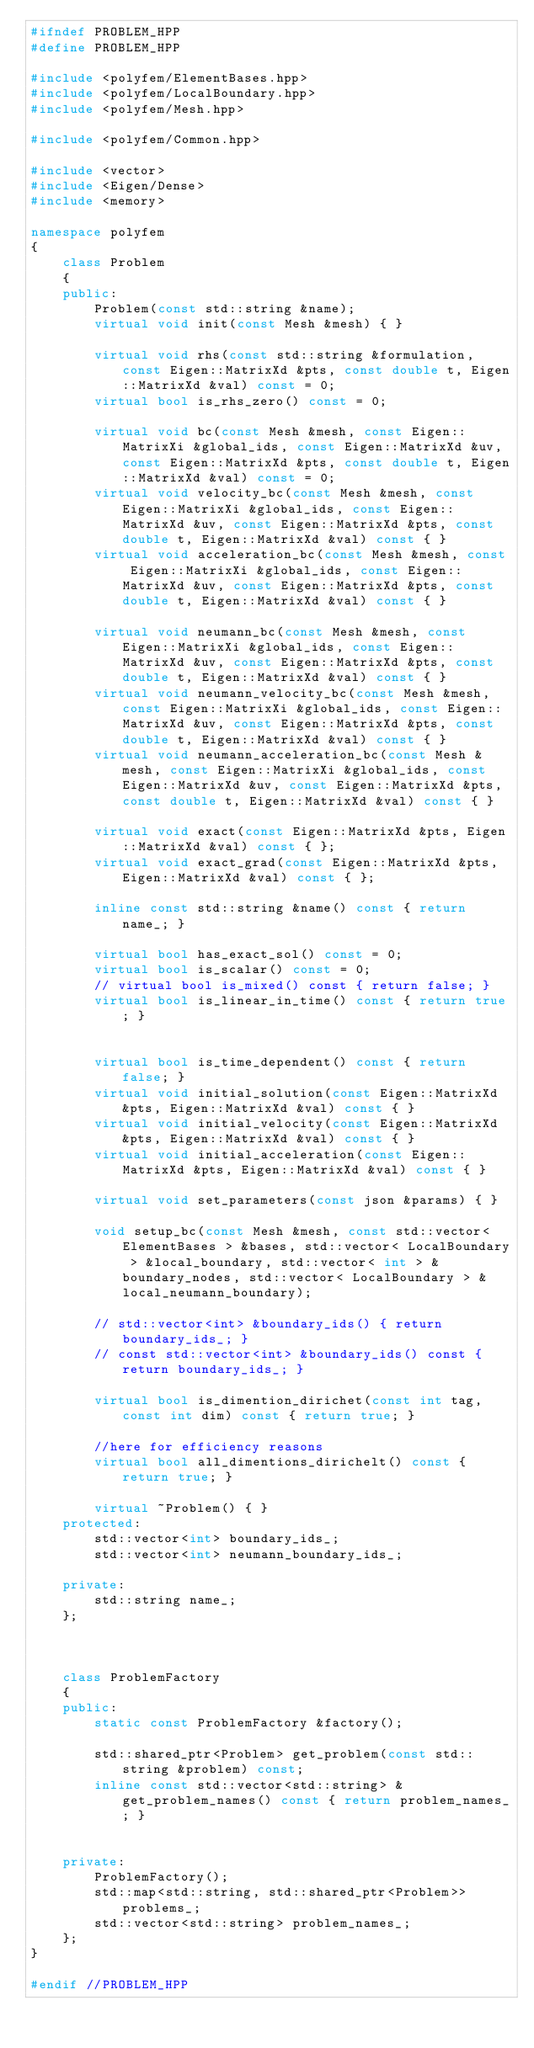Convert code to text. <code><loc_0><loc_0><loc_500><loc_500><_C++_>#ifndef PROBLEM_HPP
#define PROBLEM_HPP

#include <polyfem/ElementBases.hpp>
#include <polyfem/LocalBoundary.hpp>
#include <polyfem/Mesh.hpp>

#include <polyfem/Common.hpp>

#include <vector>
#include <Eigen/Dense>
#include <memory>

namespace polyfem
{
	class Problem
	{
	public:
		Problem(const std::string &name);
		virtual void init(const Mesh &mesh) { }

		virtual void rhs(const std::string &formulation, const Eigen::MatrixXd &pts, const double t, Eigen::MatrixXd &val) const = 0;
		virtual bool is_rhs_zero() const = 0;

		virtual void bc(const Mesh &mesh, const Eigen::MatrixXi &global_ids, const Eigen::MatrixXd &uv, const Eigen::MatrixXd &pts, const double t, Eigen::MatrixXd &val) const = 0;
		virtual void velocity_bc(const Mesh &mesh, const Eigen::MatrixXi &global_ids, const Eigen::MatrixXd &uv, const Eigen::MatrixXd &pts, const double t, Eigen::MatrixXd &val) const { }
		virtual void acceleration_bc(const Mesh &mesh, const Eigen::MatrixXi &global_ids, const Eigen::MatrixXd &uv, const Eigen::MatrixXd &pts, const double t, Eigen::MatrixXd &val) const { }

		virtual void neumann_bc(const Mesh &mesh, const Eigen::MatrixXi &global_ids, const Eigen::MatrixXd &uv, const Eigen::MatrixXd &pts, const double t, Eigen::MatrixXd &val) const { }
		virtual void neumann_velocity_bc(const Mesh &mesh, const Eigen::MatrixXi &global_ids, const Eigen::MatrixXd &uv, const Eigen::MatrixXd &pts, const double t, Eigen::MatrixXd &val) const { }
		virtual void neumann_acceleration_bc(const Mesh &mesh, const Eigen::MatrixXi &global_ids, const Eigen::MatrixXd &uv, const Eigen::MatrixXd &pts, const double t, Eigen::MatrixXd &val) const { }

		virtual void exact(const Eigen::MatrixXd &pts, Eigen::MatrixXd &val) const { };
		virtual void exact_grad(const Eigen::MatrixXd &pts, Eigen::MatrixXd &val) const { };

		inline const std::string &name() const { return name_; }

		virtual bool has_exact_sol() const = 0;
		virtual bool is_scalar() const = 0;
		// virtual bool is_mixed() const { return false; }
		virtual bool is_linear_in_time() const { return true; }


		virtual bool is_time_dependent() const { return false; }
		virtual void initial_solution(const Eigen::MatrixXd &pts, Eigen::MatrixXd &val) const { }
		virtual void initial_velocity(const Eigen::MatrixXd &pts, Eigen::MatrixXd &val) const { }
		virtual void initial_acceleration(const Eigen::MatrixXd &pts, Eigen::MatrixXd &val) const { }

		virtual void set_parameters(const json &params) { }

		void setup_bc(const Mesh &mesh, const std::vector< ElementBases > &bases, std::vector< LocalBoundary > &local_boundary, std::vector< int > &boundary_nodes, std::vector< LocalBoundary > &local_neumann_boundary);

		// std::vector<int> &boundary_ids() { return boundary_ids_; }
		// const std::vector<int> &boundary_ids() const { return boundary_ids_; }

		virtual bool is_dimention_dirichet(const int tag, const int dim) const { return true; }

		//here for efficiency reasons
		virtual bool all_dimentions_dirichelt() const { return true; }

		virtual ~Problem() { }
	protected:
		std::vector<int> boundary_ids_;
		std::vector<int> neumann_boundary_ids_;

	private:
		std::string name_;
	};



	class ProblemFactory
	{
	public:
		static const ProblemFactory &factory();

		std::shared_ptr<Problem> get_problem(const std::string &problem) const;
		inline const std::vector<std::string> &get_problem_names() const { return problem_names_; }


	private:
		ProblemFactory();
		std::map<std::string, std::shared_ptr<Problem>> problems_;
		std::vector<std::string> problem_names_;
	};
}

#endif //PROBLEM_HPP

</code> 